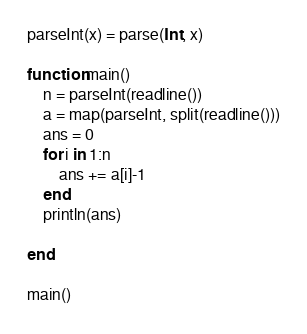Convert code to text. <code><loc_0><loc_0><loc_500><loc_500><_Julia_>parseInt(x) = parse(Int, x)

function main()
    n = parseInt(readline())
    a = map(parseInt, split(readline()))
    ans = 0
    for i in 1:n
        ans += a[i]-1
    end
    println(ans)

end

main()</code> 